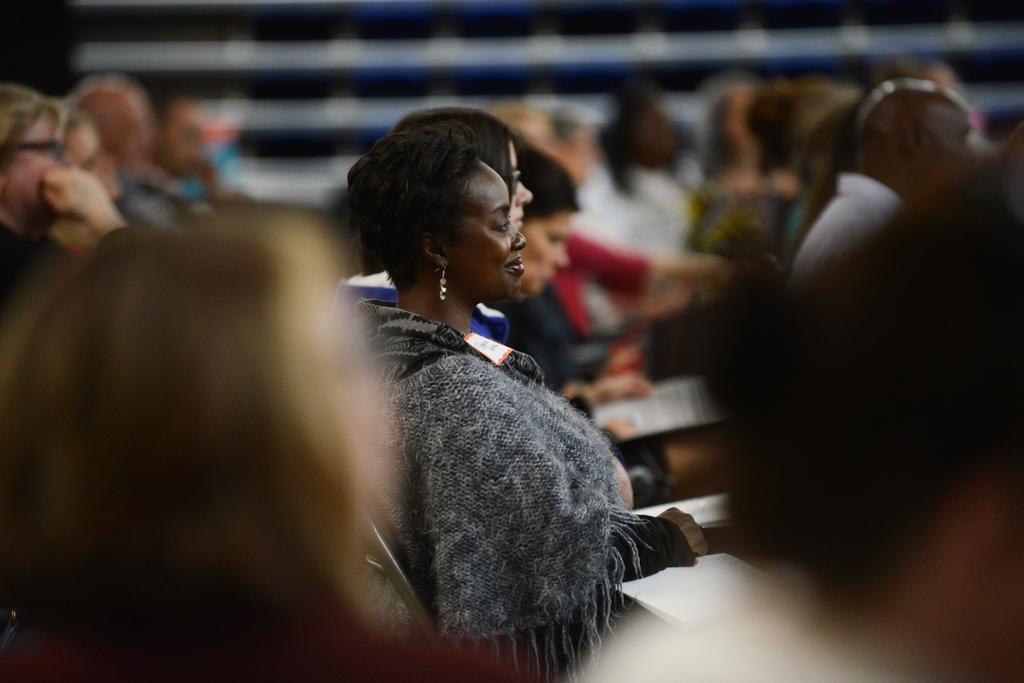How many people are in the image? There are persons in the image. What are the persons doing in the image? The persons are sitting in chairs. Can you tell me how many cracks are visible on the woman's face in the image? There is no woman present in the image, and therefore no cracks on her face can be observed. 